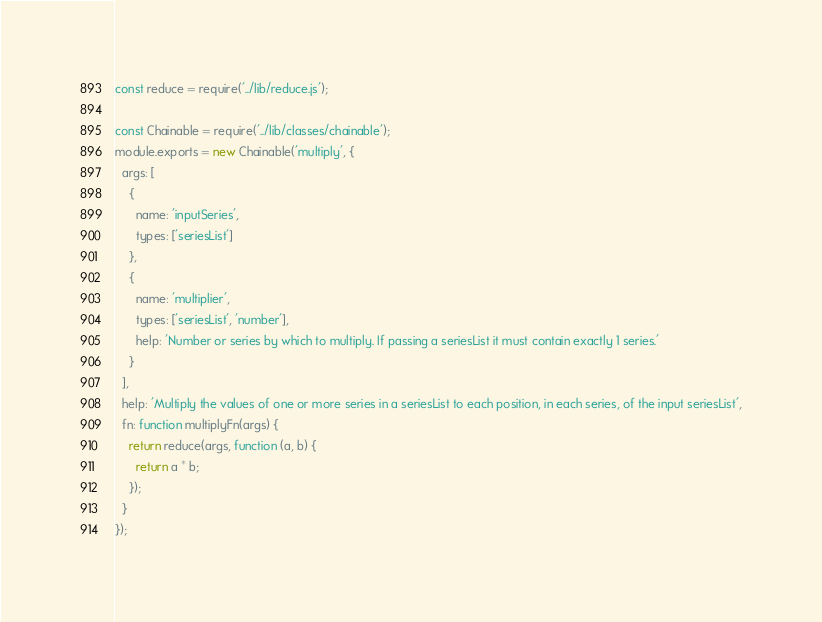Convert code to text. <code><loc_0><loc_0><loc_500><loc_500><_JavaScript_>const reduce = require('../lib/reduce.js');

const Chainable = require('../lib/classes/chainable');
module.exports = new Chainable('multiply', {
  args: [
    {
      name: 'inputSeries',
      types: ['seriesList']
    },
    {
      name: 'multiplier',
      types: ['seriesList', 'number'],
      help: 'Number or series by which to multiply. If passing a seriesList it must contain exactly 1 series.'
    }
  ],
  help: 'Multiply the values of one or more series in a seriesList to each position, in each series, of the input seriesList',
  fn: function multiplyFn(args) {
    return reduce(args, function (a, b) {
      return a * b;
    });
  }
});
</code> 